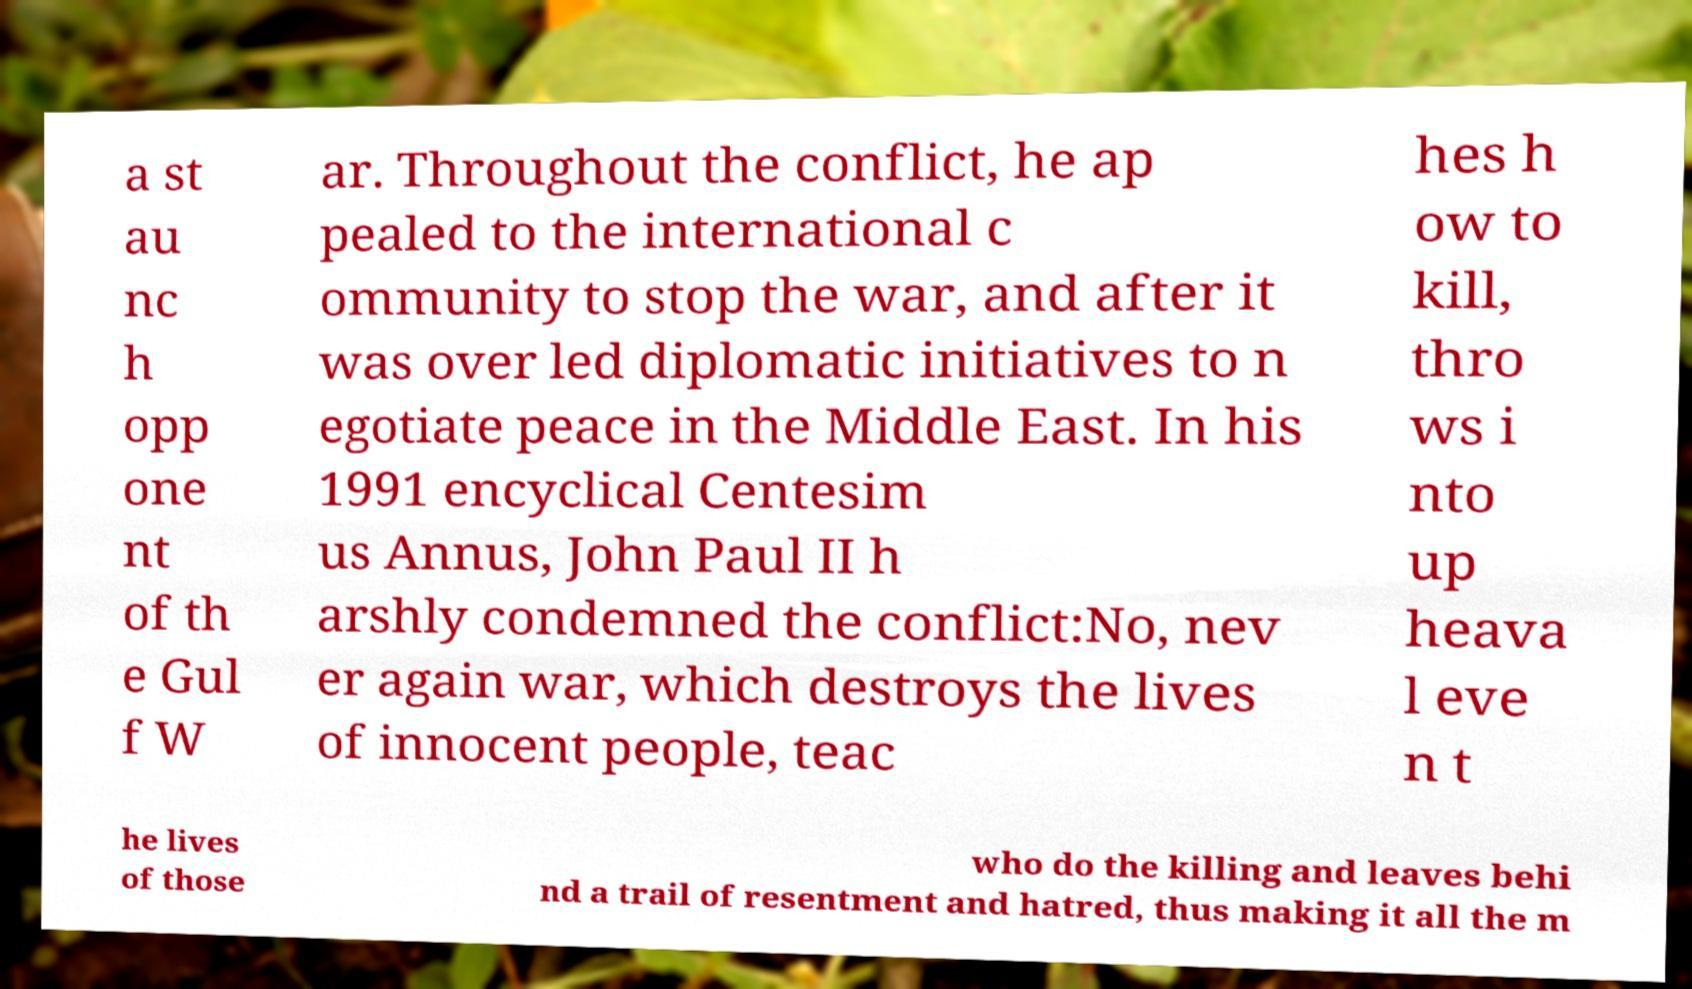Please identify and transcribe the text found in this image. a st au nc h opp one nt of th e Gul f W ar. Throughout the conflict, he ap pealed to the international c ommunity to stop the war, and after it was over led diplomatic initiatives to n egotiate peace in the Middle East. In his 1991 encyclical Centesim us Annus, John Paul II h arshly condemned the conflict:No, nev er again war, which destroys the lives of innocent people, teac hes h ow to kill, thro ws i nto up heava l eve n t he lives of those who do the killing and leaves behi nd a trail of resentment and hatred, thus making it all the m 